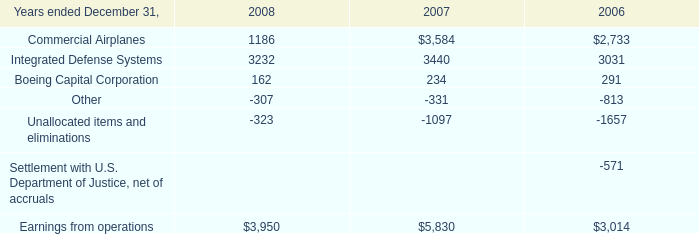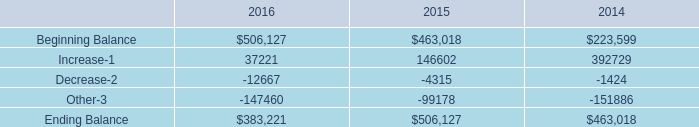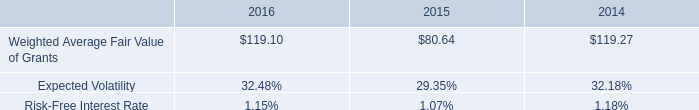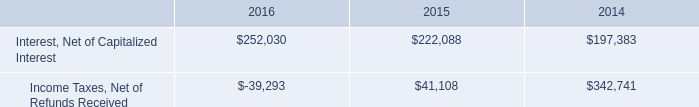what is the increase observed in the interest net of capitalized interest during 2015 and 2016? 
Computations: ((252030 / 222088) - 1)
Answer: 0.13482. 